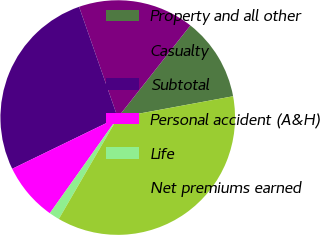Convert chart to OTSL. <chart><loc_0><loc_0><loc_500><loc_500><pie_chart><fcel>Property and all other<fcel>Casualty<fcel>Subtotal<fcel>Personal accident (A&H)<fcel>Life<fcel>Net premiums earned<nl><fcel>11.47%<fcel>15.97%<fcel>26.85%<fcel>7.98%<fcel>1.45%<fcel>36.28%<nl></chart> 